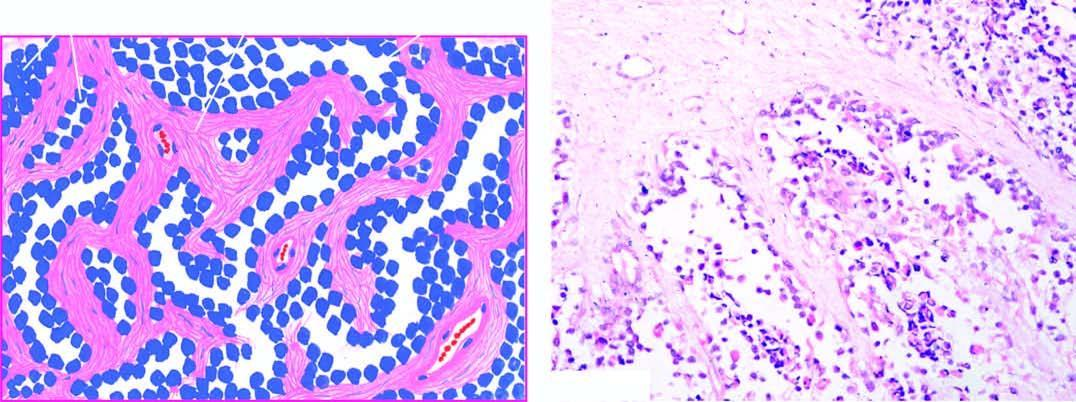re the fibrous trabeculae lined by small, dark, undifferentiated tumour cells, with some cells floating in the alveolar spaces?
Answer the question using a single word or phrase. Yes 